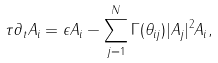Convert formula to latex. <formula><loc_0><loc_0><loc_500><loc_500>\tau \partial _ { t } A _ { i } = \epsilon A _ { i } - \sum _ { j = 1 } ^ { N } \Gamma ( \theta _ { i j } ) | { A _ { j } } | ^ { 2 } A _ { i } ,</formula> 